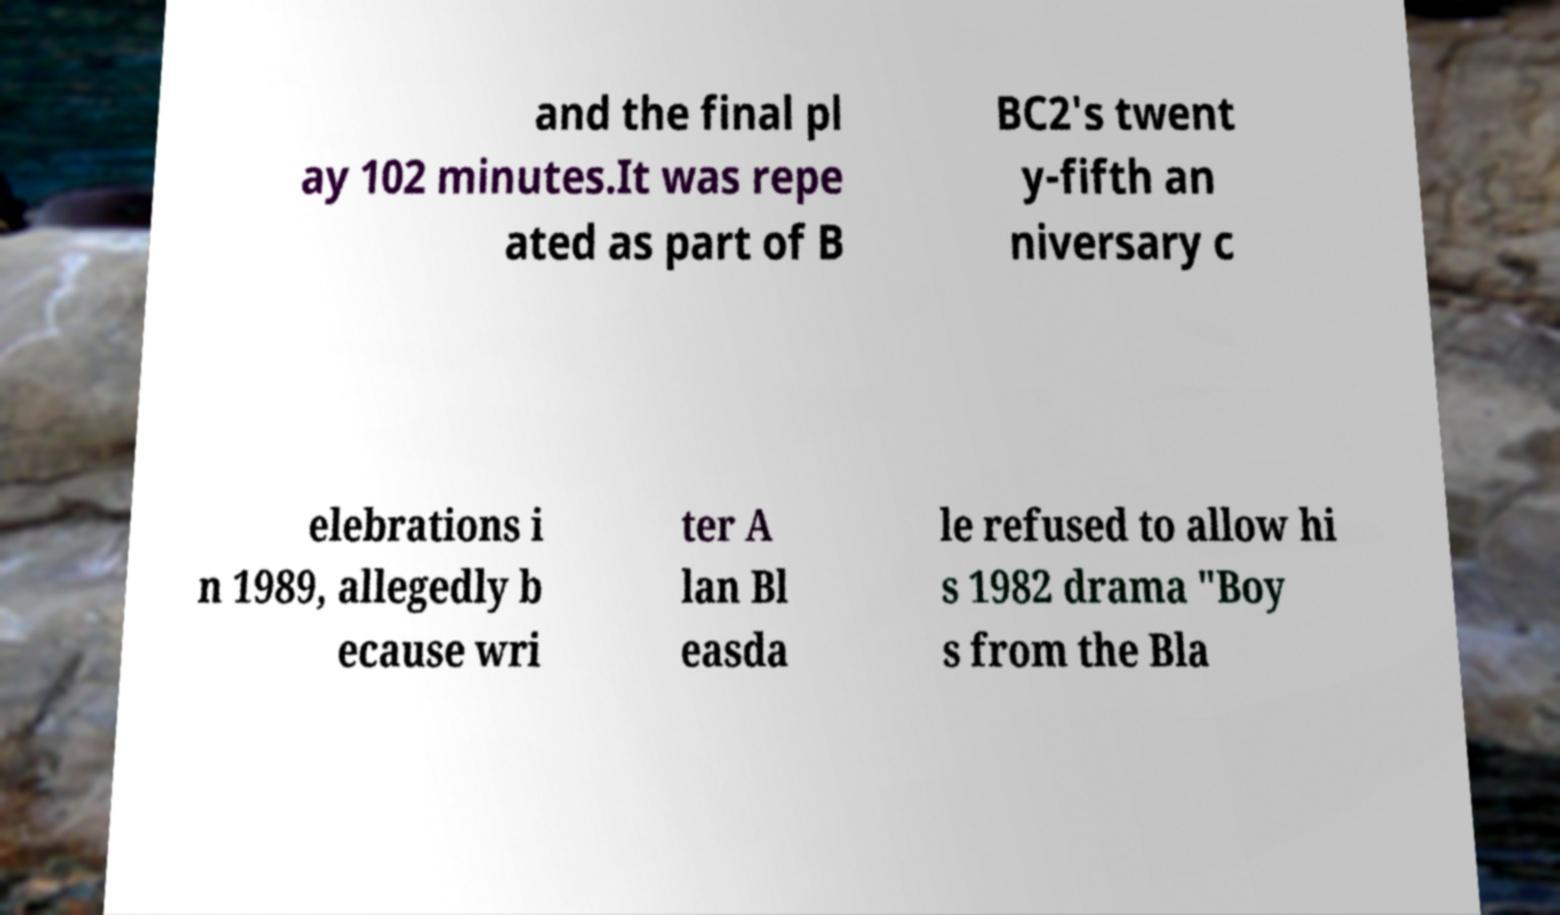For documentation purposes, I need the text within this image transcribed. Could you provide that? and the final pl ay 102 minutes.It was repe ated as part of B BC2's twent y-fifth an niversary c elebrations i n 1989, allegedly b ecause wri ter A lan Bl easda le refused to allow hi s 1982 drama "Boy s from the Bla 